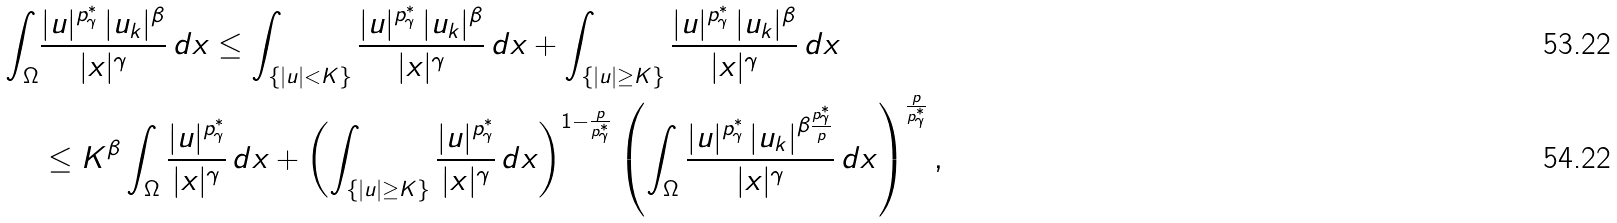Convert formula to latex. <formula><loc_0><loc_0><loc_500><loc_500>\int _ { \Omega } & \frac { | u | ^ { p ^ { * } _ { \gamma } } \, | u _ { k } | ^ { \beta } } { | x | ^ { \gamma } } \, d x \leq \int _ { \{ | u | < K \} } \frac { | u | ^ { p ^ { * } _ { \gamma } } \, | u _ { k } | ^ { \beta } } { | x | ^ { \gamma } } \, d x + \int _ { \{ | u | \geq K \} } \frac { | u | ^ { p ^ { * } _ { \gamma } } \, | u _ { k } | ^ { \beta } } { | x | ^ { \gamma } } \, d x \\ & \leq K ^ { \beta } \int _ { \Omega } \frac { | u | ^ { p ^ { * } _ { \gamma } } } { | x | ^ { \gamma } } \, d x + \left ( \int _ { \{ | u | \geq K \} } \frac { | u | ^ { p ^ { * } _ { \gamma } } } { | x | ^ { \gamma } } \, d x \right ) ^ { 1 - \frac { p } { p ^ { * } _ { \gamma } } } \left ( \int _ { \Omega } \frac { | u | ^ { p ^ { * } _ { \gamma } } \, | u _ { k } | ^ { \beta \frac { p ^ { * } _ { \gamma } } { p } } } { | x | ^ { \gamma } } \, d x \right ) ^ { \frac { p } { p ^ { * } _ { \gamma } } } ,</formula> 